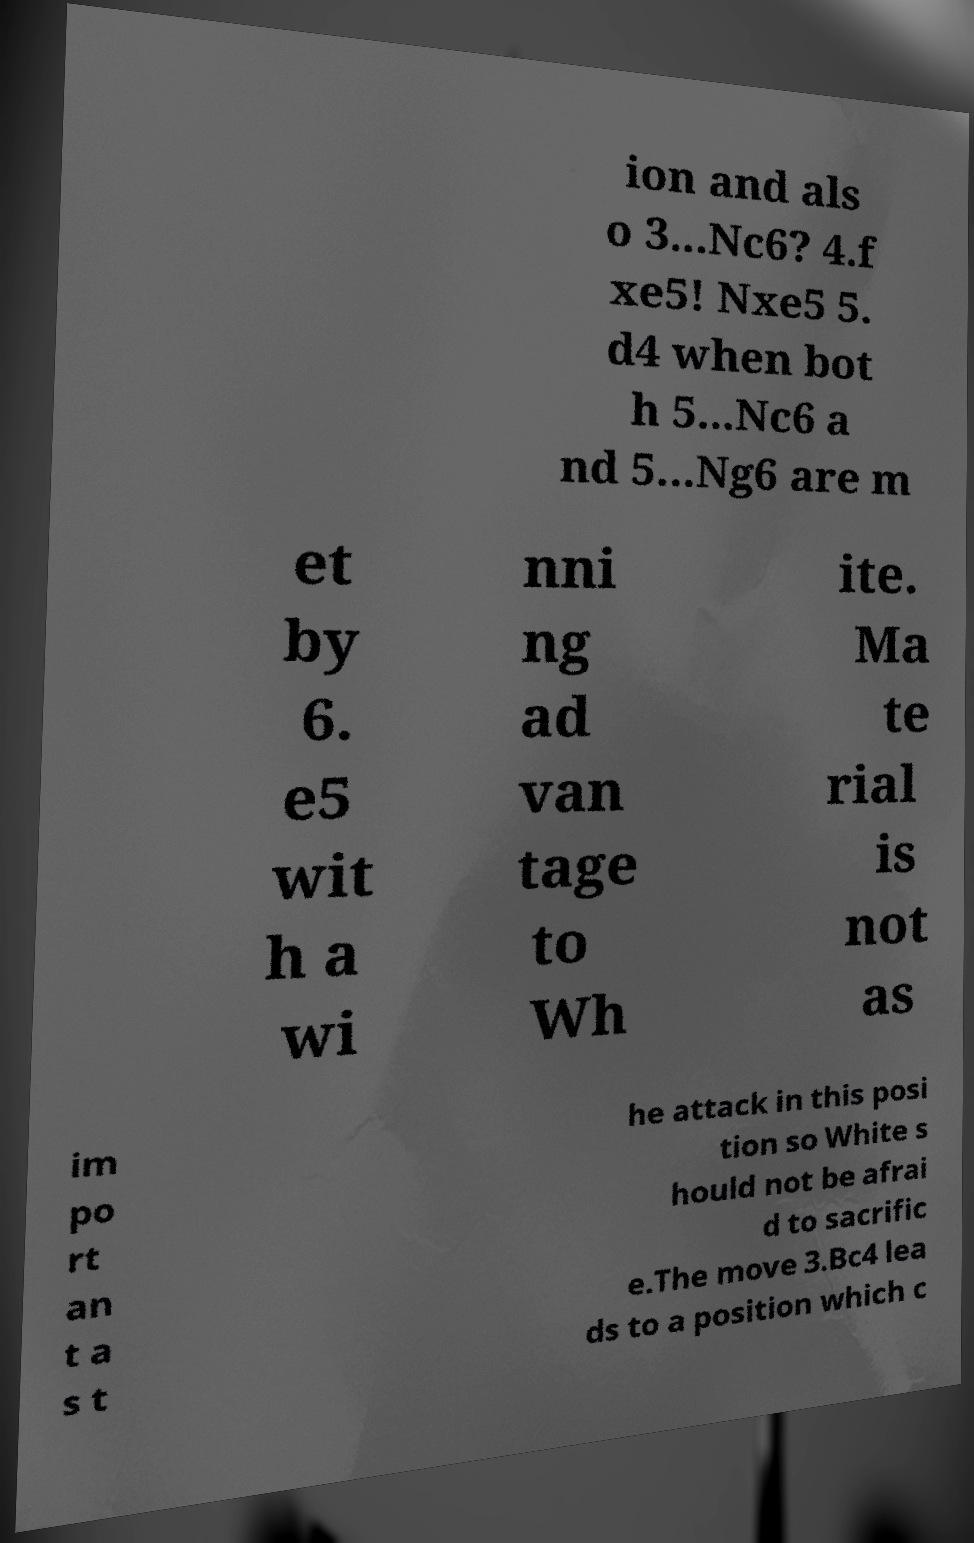Can you read and provide the text displayed in the image?This photo seems to have some interesting text. Can you extract and type it out for me? ion and als o 3...Nc6? 4.f xe5! Nxe5 5. d4 when bot h 5...Nc6 a nd 5...Ng6 are m et by 6. e5 wit h a wi nni ng ad van tage to Wh ite. Ma te rial is not as im po rt an t a s t he attack in this posi tion so White s hould not be afrai d to sacrific e.The move 3.Bc4 lea ds to a position which c 